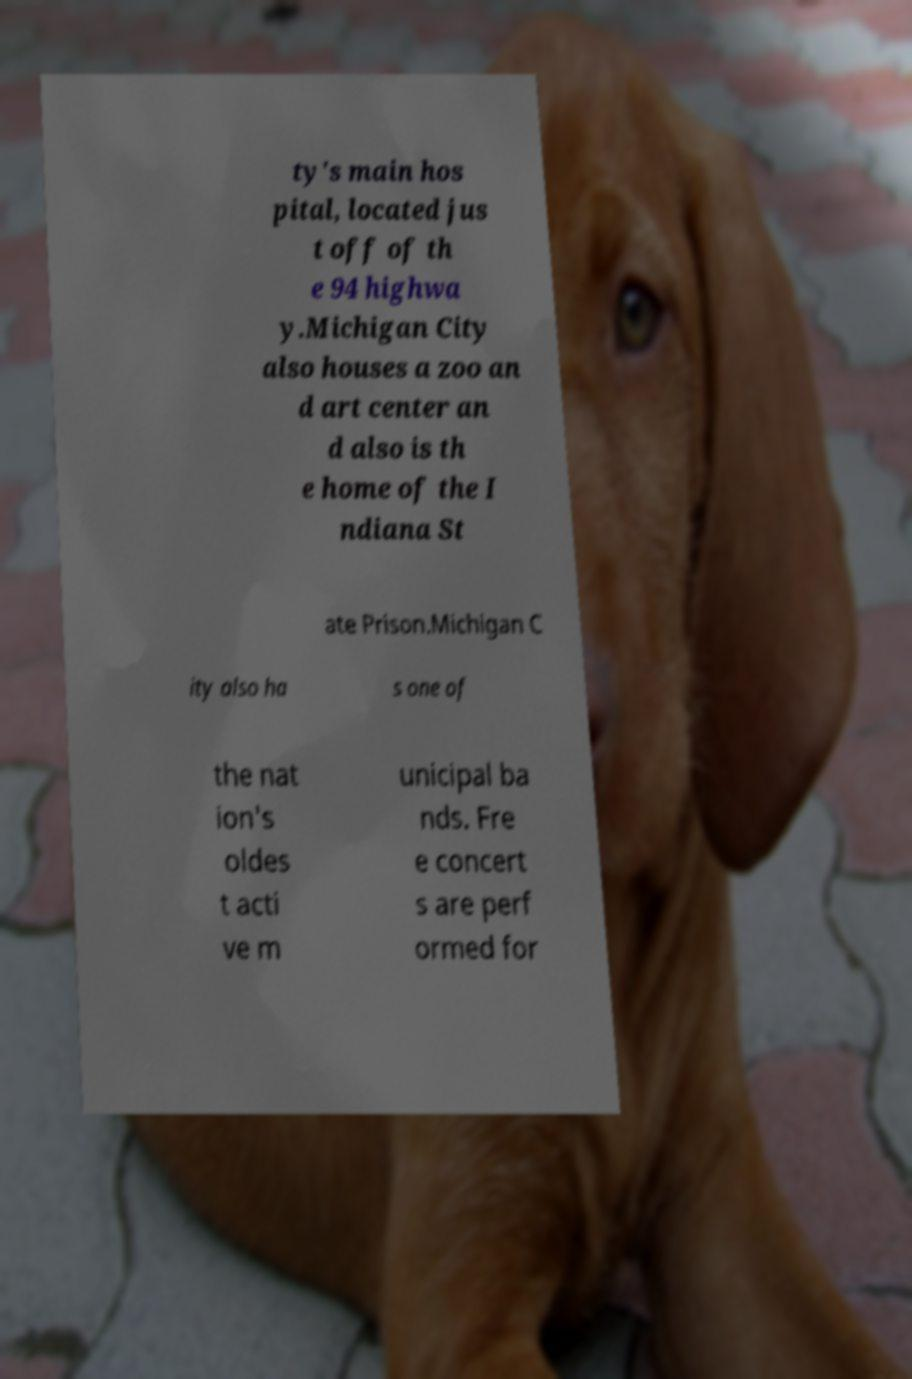Could you extract and type out the text from this image? ty's main hos pital, located jus t off of th e 94 highwa y.Michigan City also houses a zoo an d art center an d also is th e home of the I ndiana St ate Prison.Michigan C ity also ha s one of the nat ion's oldes t acti ve m unicipal ba nds. Fre e concert s are perf ormed for 